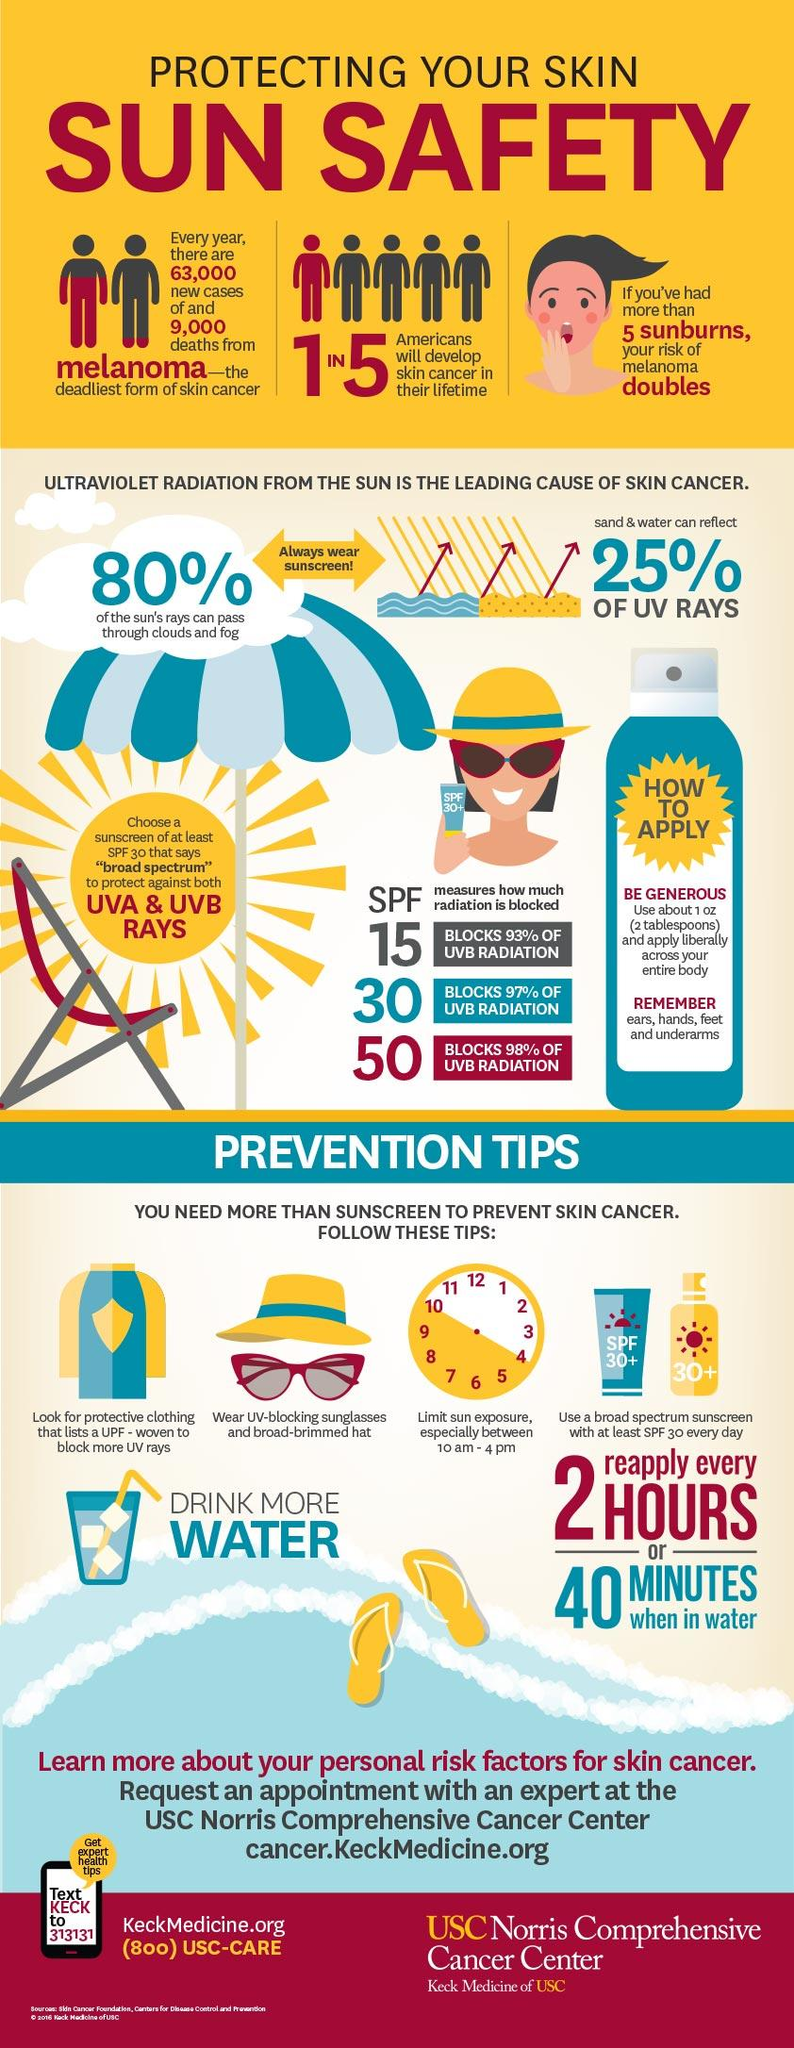Indicate a few pertinent items in this graphic. Five prevention tips are mentioned to avoid skin cancer. Approximately 20% of UV rays cannot pass through clouds and fog, which can increase the risk of skin damage and skin cancer. It is estimated that 75% of UV rays cannot be reflected by sand and water. 